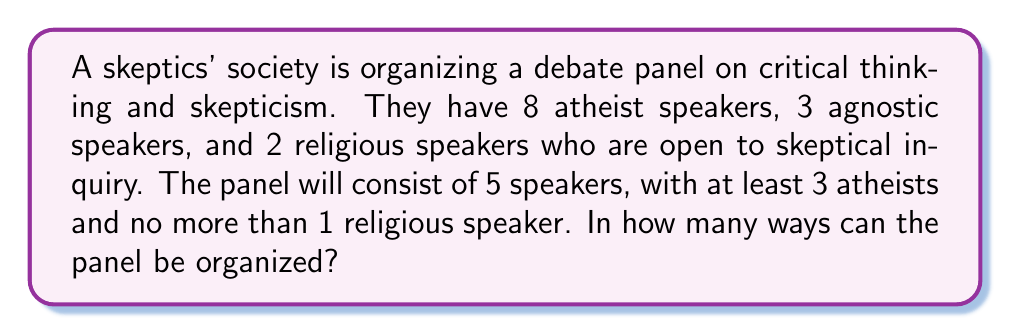What is the answer to this math problem? Let's approach this step-by-step:

1) We need to select 5 speakers in total, with at least 3 atheists and no more than 1 religious speaker.

2) We can break this down into cases:
   Case 1: 3 atheists, 1 agnostic, 1 religious
   Case 2: 3 atheists, 2 agnostics, 0 religious
   Case 3: 4 atheists, 1 agnostic, 0 religious
   Case 4: 4 atheists, 0 agnostic, 1 religious
   Case 5: 5 atheists, 0 agnostic, 0 religious

3) Let's calculate each case:

   Case 1: $\binom{8}{3} \times \binom{3}{1} \times \binom{2}{1} = 56 \times 3 \times 2 = 336$

   Case 2: $\binom{8}{3} \times \binom{3}{2} = 56 \times 3 = 168$

   Case 3: $\binom{8}{4} \times \binom{3}{1} = 70 \times 3 = 210$

   Case 4: $\binom{8}{4} \times \binom{2}{1} = 70 \times 2 = 140$

   Case 5: $\binom{8}{5} = 56$

4) The total number of ways is the sum of all these cases:

   $336 + 168 + 210 + 140 + 56 = 910$

Therefore, there are 910 ways to organize the panel.
Answer: 910 